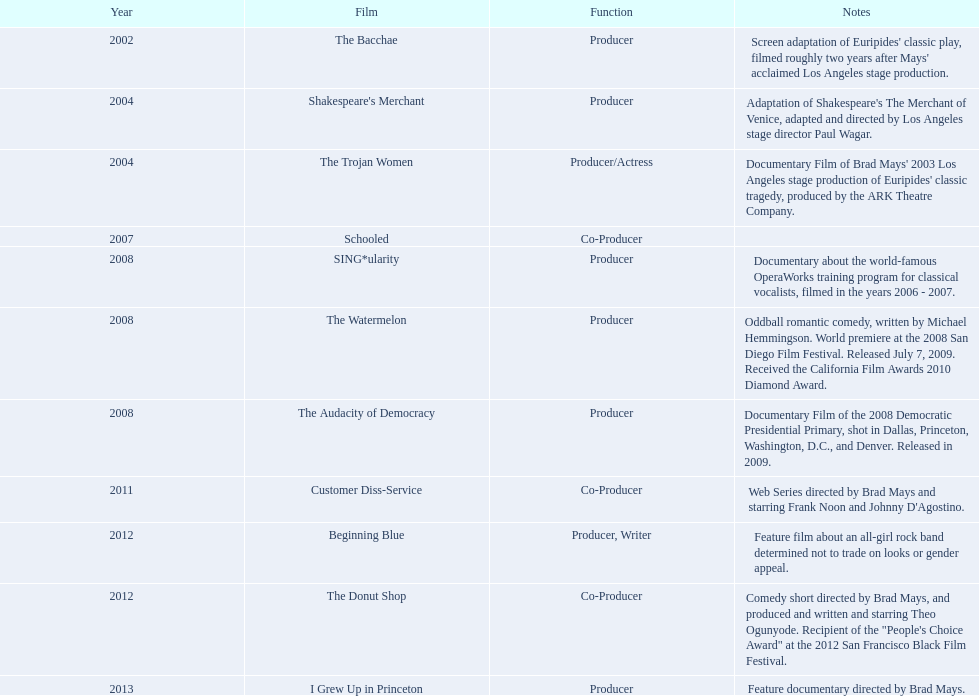Can you name a documentary film made after 2008 but before 2011? The Audacity of Democracy. 